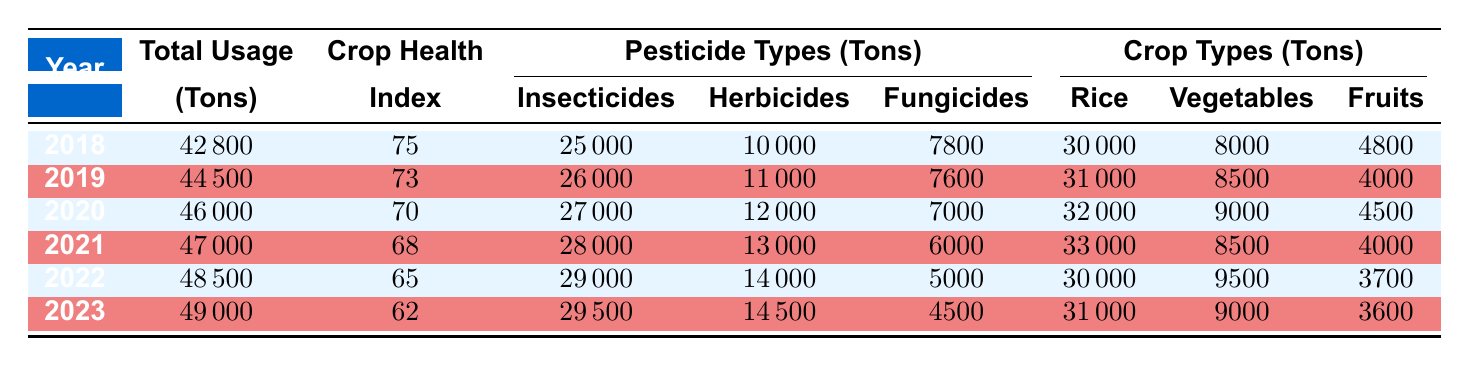What was the total pesticide usage in 2021? The total pesticide usage for 2021 is listed in the table under the "Total Usage" column for that year, which is 47000 tons.
Answer: 47000 tons Which type of pesticide had the highest usage in 2020? Looking at the "Pesticide Types" columns for 2020, Insecticides have the highest usage at 27000 tons, compared to Herbicides at 12000 tons and Fungicides at 7000 tons.
Answer: Insecticides What is the difference in the Crop Health Index between 2018 and 2023? The Crop Health Index for 2018 is 75, and for 2023 it is 62. The difference is 75 - 62 = 13.
Answer: 13 Did the total usage of pesticides increase every year from 2018 to 2023? By examining the "Total Usage" values year by year in the table, the values are 42800 (2018), 44500 (2019), 46000 (2020), 47000 (2021), 48500 (2022), and 49000 (2023). There is a consistent increase each year.
Answer: Yes What was the total usage of Fungicides in 2022 and 2023 combined? Adding the Fungicide usage in 2022 (5000 tons) and 2023 (4500 tons) gives a total of 5000 + 4500 = 9500 tons.
Answer: 9500 tons How many tons of Herbicides were used in 2020 compared to 2021? The table shows Herbicide usage of 12000 tons in 2020 and 13000 tons in 2021. The difference is 13000 - 12000 = 1000 tons more in 2021.
Answer: 1000 tons Was the usage of pesticides in 2019 greater than that in 2020? The totals for 2019 and 2020 are 44500 tons and 46000 tons, respectively. Since 44500 is less than 46000, the statement is false.
Answer: No What was the average Crop Health Index from 2018 to 2023? The Crop Health Indices from 2018 to 2023 are 75, 73, 70, 68, 65, and 62. The average is calculated as (75 + 73 + 70 + 68 + 65 + 62) / 6 = 69.
Answer: 69 